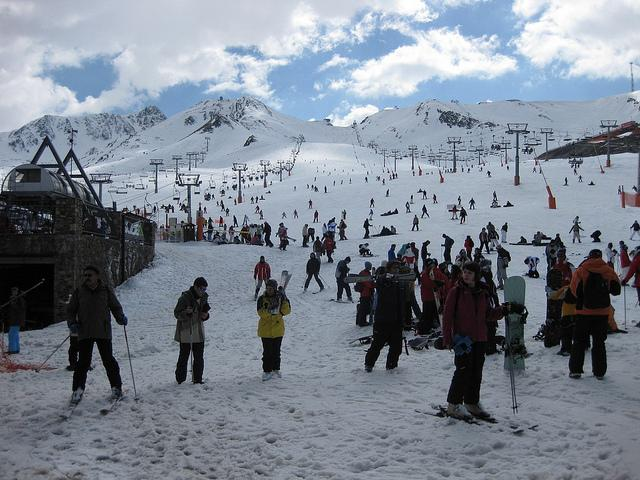How could someone near here gain elevation without expending a lot of energy?

Choices:
A) ski lift
B) jog
C) catch taxi
D) ski uphill ski lift 